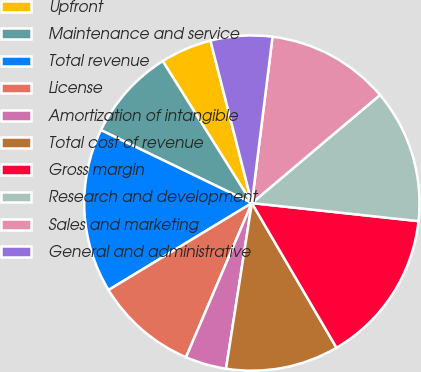Convert chart to OTSL. <chart><loc_0><loc_0><loc_500><loc_500><pie_chart><fcel>Upfront<fcel>Maintenance and service<fcel>Total revenue<fcel>License<fcel>Amortization of intangible<fcel>Total cost of revenue<fcel>Gross margin<fcel>Research and development<fcel>Sales and marketing<fcel>General and administrative<nl><fcel>4.95%<fcel>8.91%<fcel>15.84%<fcel>9.9%<fcel>3.96%<fcel>10.89%<fcel>14.85%<fcel>12.87%<fcel>11.88%<fcel>5.94%<nl></chart> 